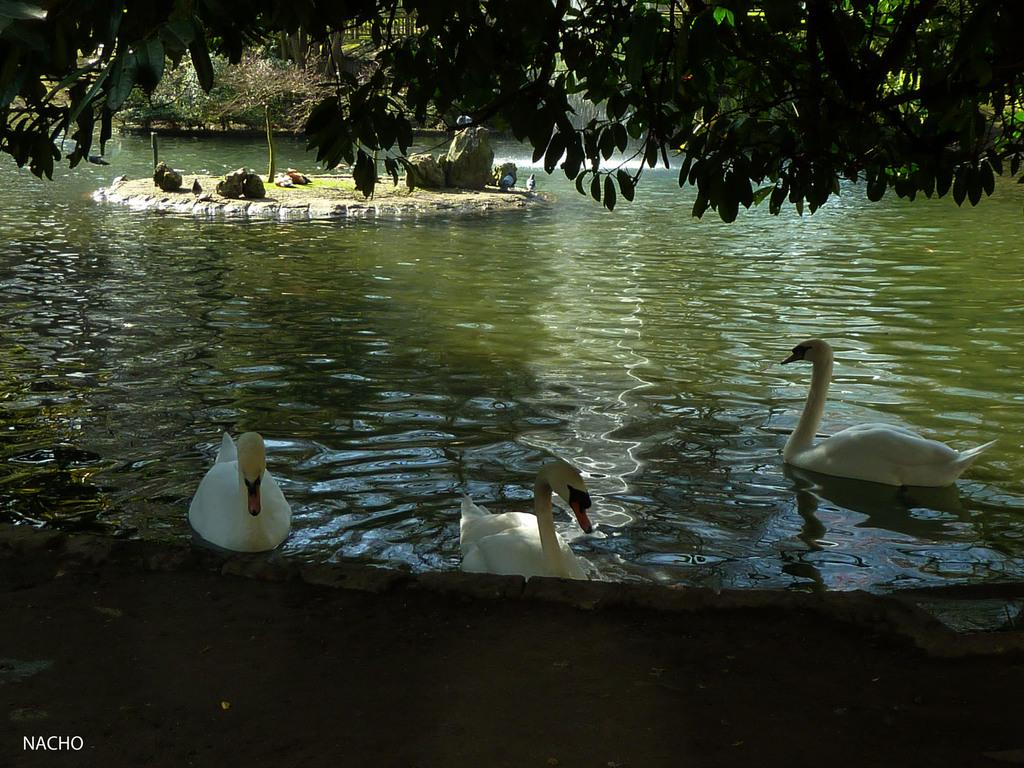What type of natural elements can be seen in the image? There are trees and water visible in the image. What objects can be found on the ground in the image? There are stones in the image. What animals are present on the water in the image? There are birds on the water in the image. Is there any text present in the image? Yes, there is some text at the bottom of the image. What type of calendar is hanging on the tree in the image? There is no calendar present in the image; it features trees, stones, birds, water, and text. What does the peace symbol look like in the image? There is no peace symbol present in the image. 